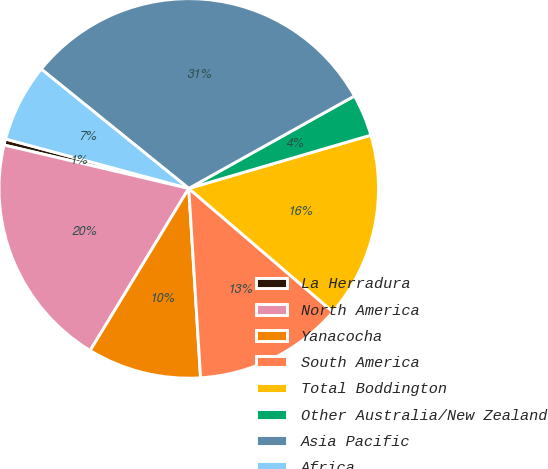Convert chart to OTSL. <chart><loc_0><loc_0><loc_500><loc_500><pie_chart><fcel>La Herradura<fcel>North America<fcel>Yanacocha<fcel>South America<fcel>Total Boddington<fcel>Other Australia/New Zealand<fcel>Asia Pacific<fcel>Africa<nl><fcel>0.52%<fcel>19.98%<fcel>9.69%<fcel>12.74%<fcel>15.8%<fcel>3.57%<fcel>31.08%<fcel>6.63%<nl></chart> 